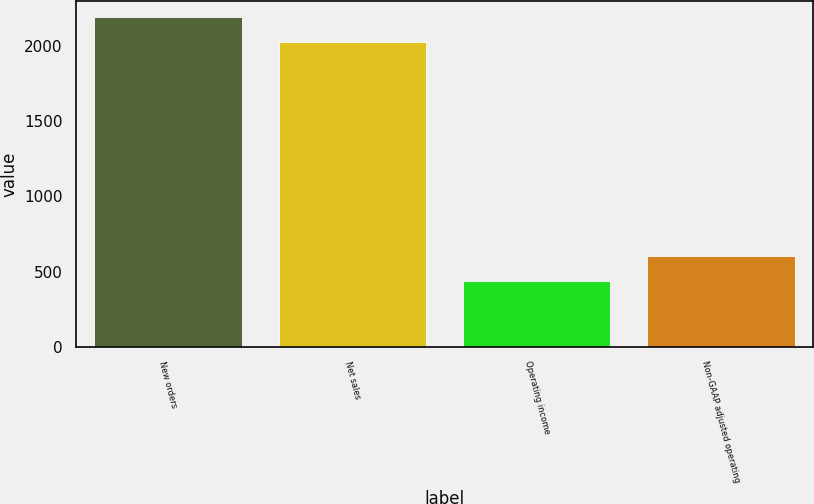Convert chart. <chart><loc_0><loc_0><loc_500><loc_500><bar_chart><fcel>New orders<fcel>Net sales<fcel>Operating income<fcel>Non-GAAP adjusted operating<nl><fcel>2188.4<fcel>2023<fcel>436<fcel>601.4<nl></chart> 